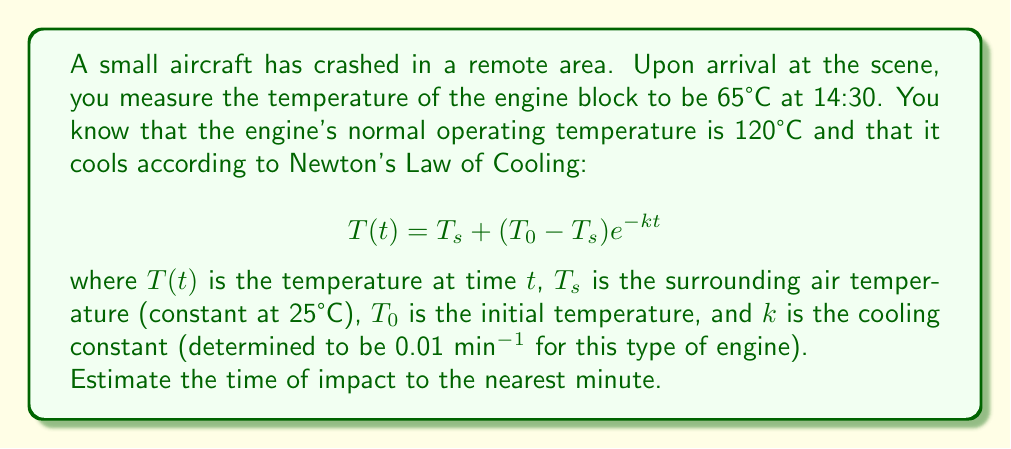Show me your answer to this math problem. To solve this problem, we need to use Newton's Law of Cooling and work backwards to find the time elapsed since the crash. Let's approach this step-by-step:

1) We are given:
   $T(t) = 65°C$ (current temperature at 14:30)
   $T_s = 25°C$ (surrounding temperature)
   $T_0 = 120°C$ (initial temperature)
   $k = 0.01$ min^(-1) (cooling constant)

2) Substituting these values into the equation:

   $$65 = 25 + (120 - 25)e^{-0.01t}$$

3) Simplify:
   $$65 = 25 + 95e^{-0.01t}$$

4) Subtract 25 from both sides:
   $$40 = 95e^{-0.01t}$$

5) Divide both sides by 95:
   $$\frac{40}{95} = e^{-0.01t}$$

6) Take the natural log of both sides:
   $$\ln(\frac{40}{95}) = -0.01t$$

7) Divide both sides by -0.01:
   $$\frac{\ln(\frac{40}{95})}{-0.01} = t$$

8) Calculate:
   $$t \approx 86.85 \text{ minutes}$$

9) Round to the nearest minute:
   $$t \approx 87 \text{ minutes}$$

10) Convert 87 minutes to hours and minutes:
    87 minutes = 1 hour and 27 minutes

11) Subtract this from the time of measurement (14:30):
    14:30 - 1:27 = 13:03

Therefore, the estimated time of impact is 13:03.
Answer: 13:03 